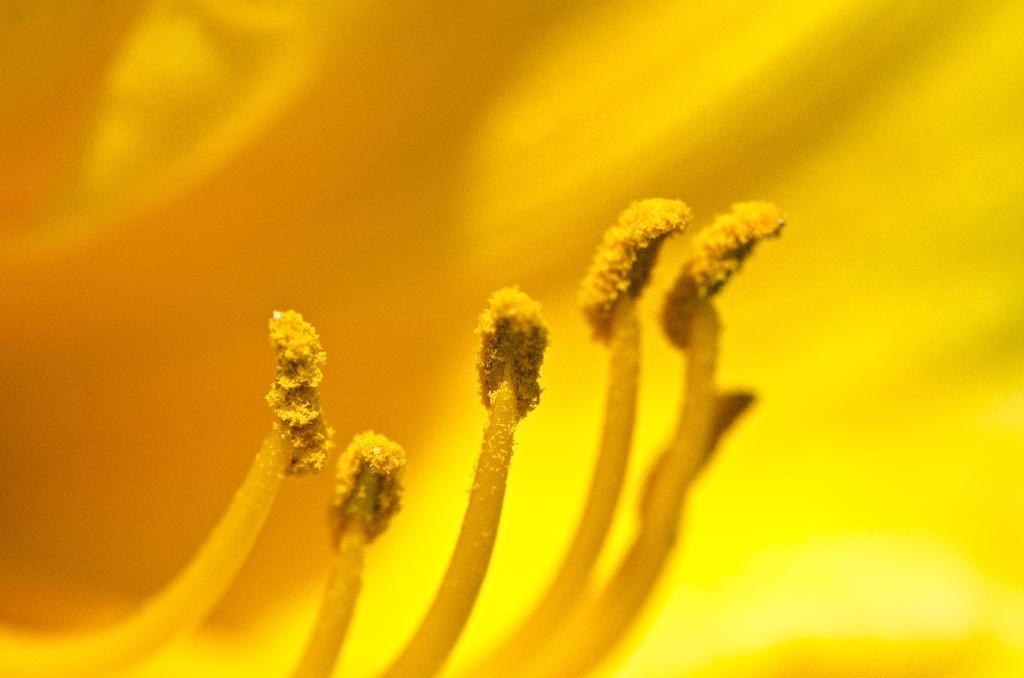What is the main subject of the image? There is a flower in the image. Can you describe the color of the flower? The flower is yellow. How many people are participating in the protest near the ocean in the image? There is no ocean or protest present in the image; it features a yellow flower. What type of hammer is being used to break the ice in the image? There is no hammer or ice present in the image; it features a yellow flower. 